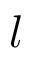<formula> <loc_0><loc_0><loc_500><loc_500>l</formula> 